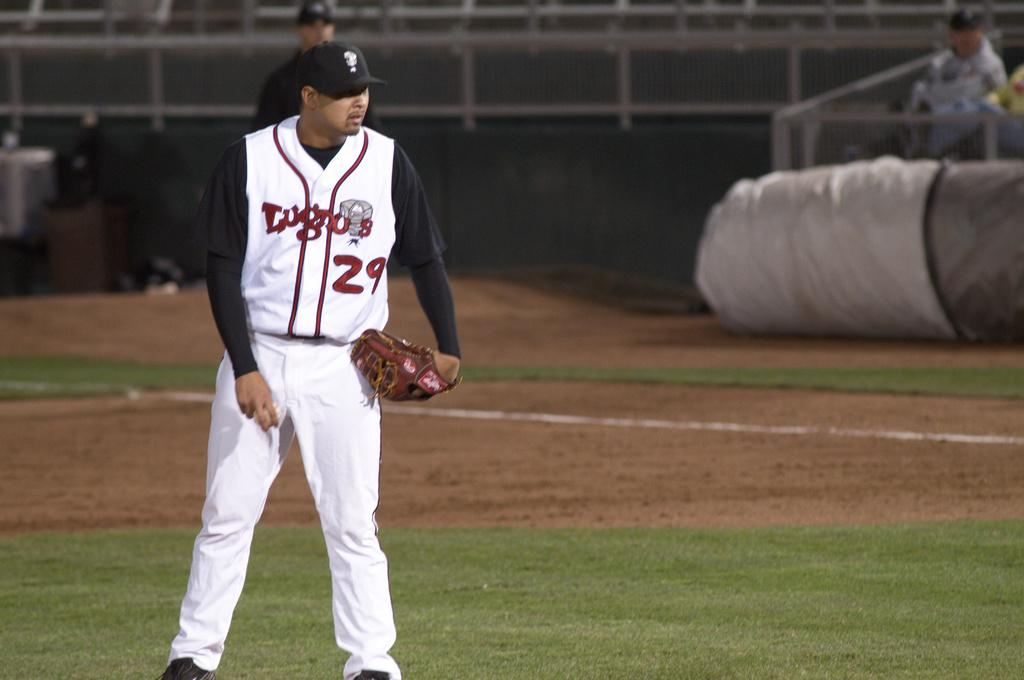<image>
Summarize the visual content of the image. a player of baseball that is wearing the number 29 